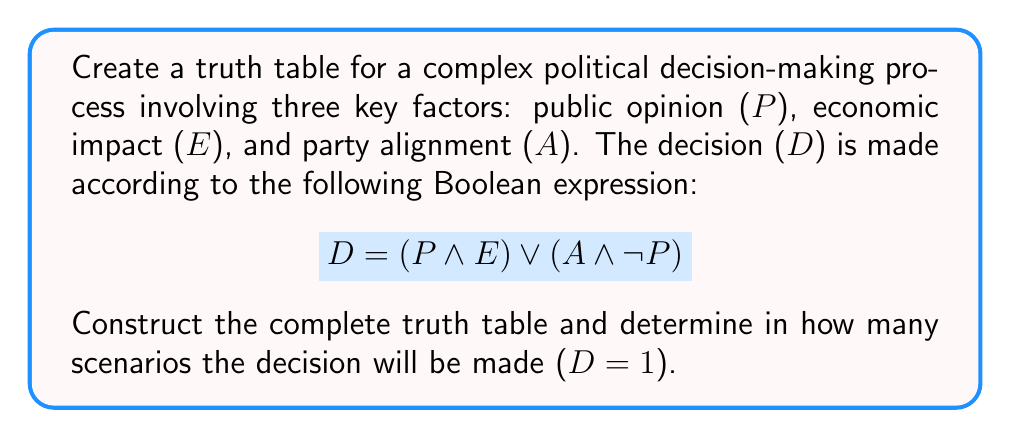Provide a solution to this math problem. Let's approach this step-by-step:

1) First, we need to identify the number of variables: P, E, and A. With 3 variables, we'll have $2^3 = 8$ rows in our truth table.

2) Now, let's create the truth table:

   P | E | A | (P ∧ E) | (A ∧ ¬P) | D = (P ∧ E) ∨ (A ∧ ¬P)
   0 | 0 | 0 |    0    |    0     |           0
   0 | 0 | 1 |    0    |    1     |           1
   0 | 1 | 0 |    0    |    0     |           0
   0 | 1 | 1 |    0    |    1     |           1
   1 | 0 | 0 |    0    |    0     |           0
   1 | 0 | 1 |    0    |    0     |           0
   1 | 1 | 0 |    1    |    0     |           1
   1 | 1 | 1 |    1    |    0     |           1

3) Let's break down the calculation for each column:
   - (P ∧ E): This is 1 only when both P and E are 1.
   - (A ∧ ¬P): This is 1 when A is 1 and P is 0.
   - D = (P ∧ E) ∨ (A ∧ ¬P): This is 1 if either (P ∧ E) or (A ∧ ¬P) is 1.

4) Now, we count the number of times D = 1 in the final column. This occurs in 4 scenarios.

This truth table demonstrates how the decision is made based on various combinations of public opinion, economic impact, and party alignment, reflecting the complex nature of political decision-making.
Answer: 4 scenarios 